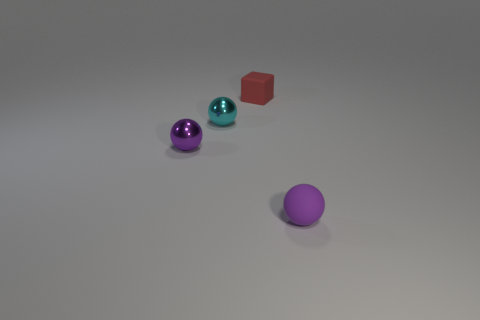Add 1 purple metal things. How many objects exist? 5 Subtract all blocks. How many objects are left? 3 Subtract all large red metal things. Subtract all purple matte spheres. How many objects are left? 3 Add 4 small purple metal spheres. How many small purple metal spheres are left? 5 Add 4 large yellow shiny objects. How many large yellow shiny objects exist? 4 Subtract 0 yellow cylinders. How many objects are left? 4 